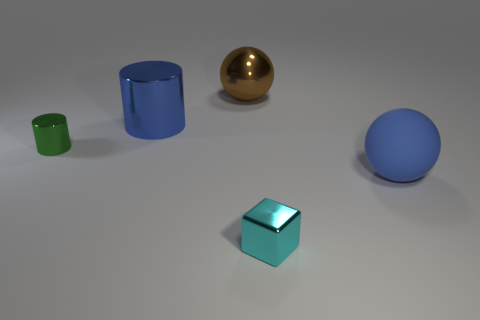Add 4 small green shiny things. How many objects exist? 9 Subtract 0 blue cubes. How many objects are left? 5 Subtract all balls. How many objects are left? 3 Subtract all large spheres. Subtract all blue metallic cylinders. How many objects are left? 2 Add 4 large things. How many large things are left? 7 Add 1 big metal spheres. How many big metal spheres exist? 2 